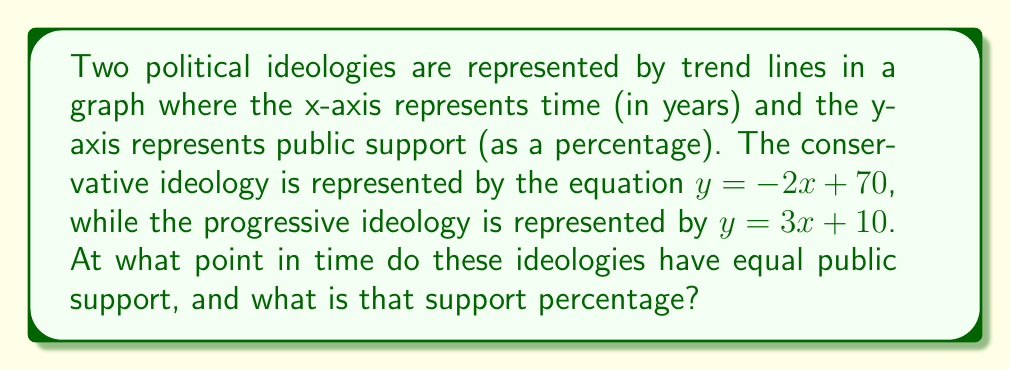Provide a solution to this math problem. To solve this problem, we need to find the intersection point of the two lines. This is where the public support for both ideologies is equal.

Step 1: Set up an equation where both lines are equal.
$-2x + 70 = 3x + 10$

Step 2: Solve for x by isolating variables on one side and constants on the other.
$-2x - 3x = 10 - 70$
$-5x = -60$

Step 3: Divide both sides by -5 to solve for x.
$x = \frac{-60}{-5} = 12$

Step 4: To find the y-coordinate (public support percentage), substitute x = 12 into either of the original equations. Let's use the conservative ideology equation:

$y = -2(12) + 70$
$y = -24 + 70 = 46$

Therefore, the ideologies have equal public support after 12 years, with 46% support for each.
Answer: (12, 46) 